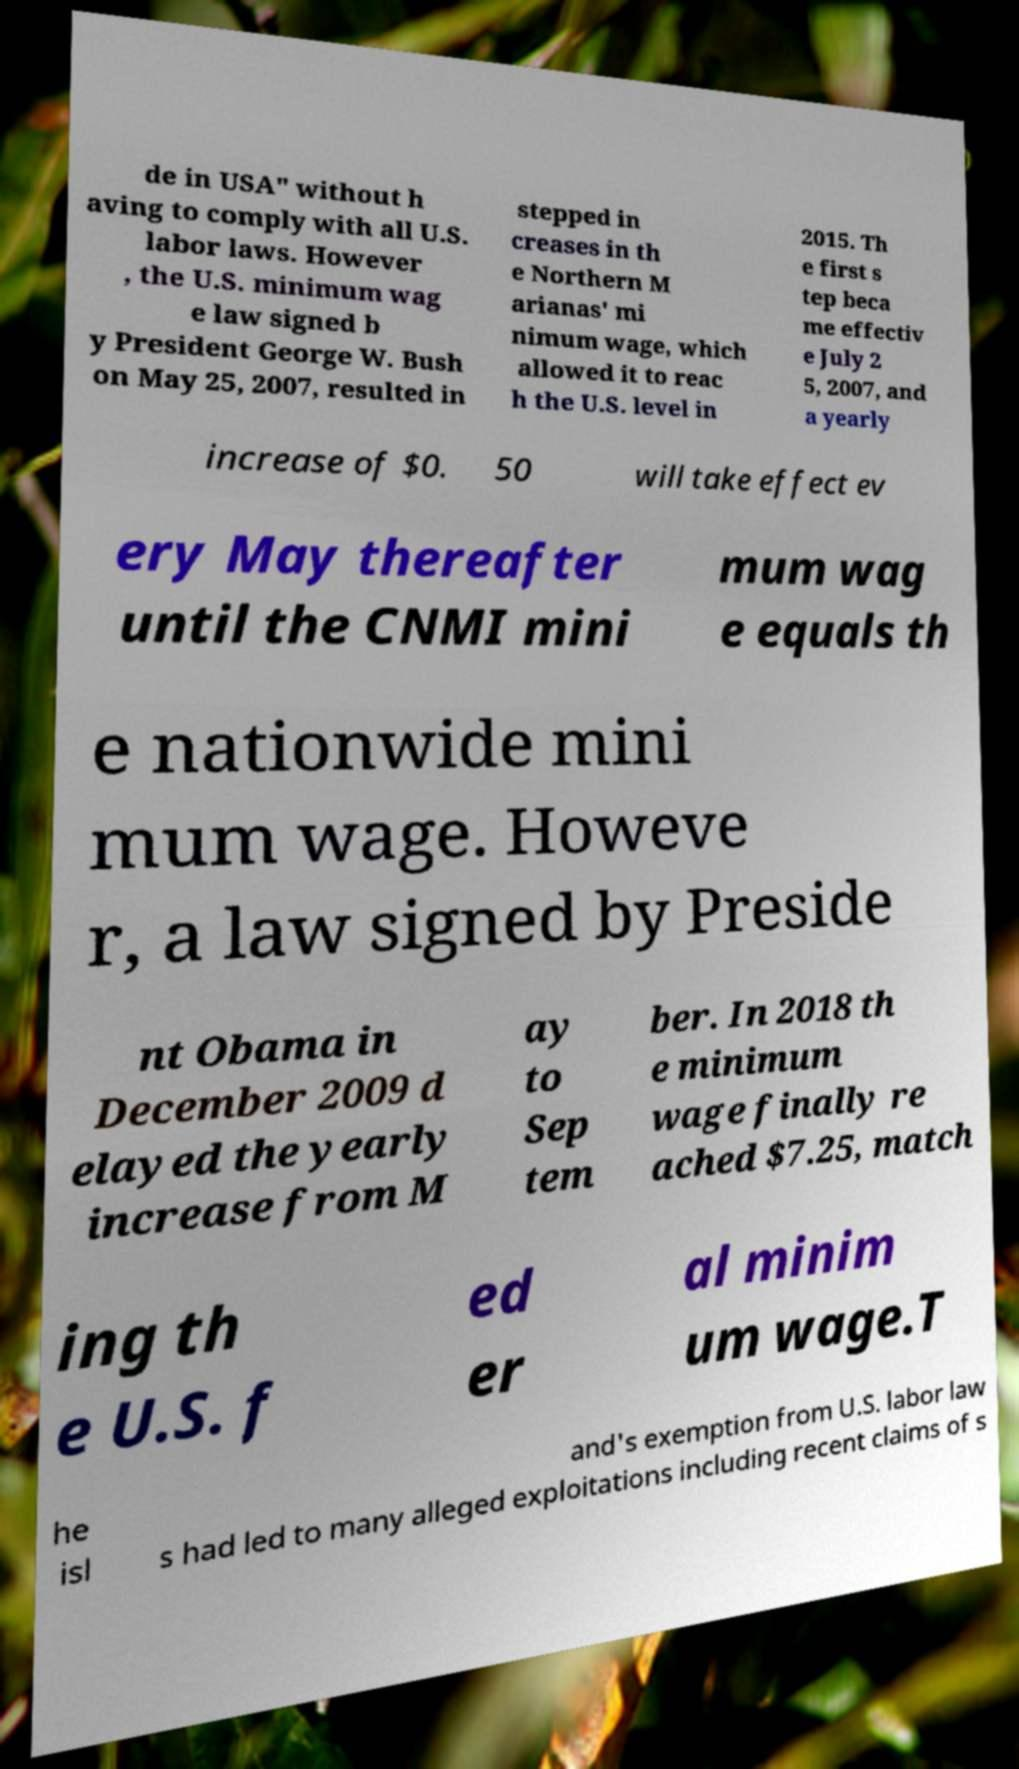Can you read and provide the text displayed in the image?This photo seems to have some interesting text. Can you extract and type it out for me? de in USA" without h aving to comply with all U.S. labor laws. However , the U.S. minimum wag e law signed b y President George W. Bush on May 25, 2007, resulted in stepped in creases in th e Northern M arianas' mi nimum wage, which allowed it to reac h the U.S. level in 2015. Th e first s tep beca me effectiv e July 2 5, 2007, and a yearly increase of $0. 50 will take effect ev ery May thereafter until the CNMI mini mum wag e equals th e nationwide mini mum wage. Howeve r, a law signed by Preside nt Obama in December 2009 d elayed the yearly increase from M ay to Sep tem ber. In 2018 th e minimum wage finally re ached $7.25, match ing th e U.S. f ed er al minim um wage.T he isl and's exemption from U.S. labor law s had led to many alleged exploitations including recent claims of s 